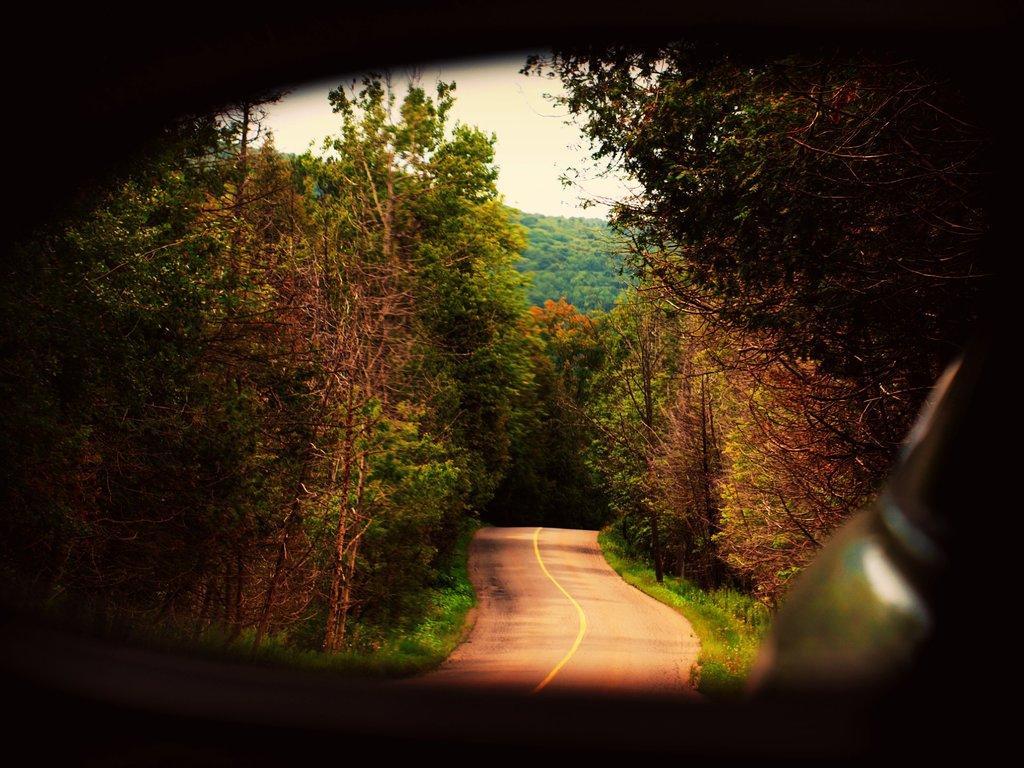Please provide a concise description of this image. In this picture I can see a road in the middle. There are trees on either side of this image, at the top there is the sky. 